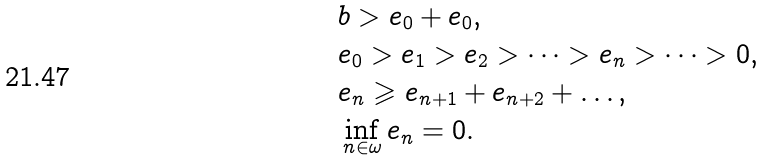Convert formula to latex. <formula><loc_0><loc_0><loc_500><loc_500>& b > e _ { 0 } + e _ { 0 } , \\ & e _ { 0 } > e _ { 1 } > e _ { 2 } > \dots > e _ { n } > \dots > 0 , \\ & e _ { n } \geqslant e _ { n + 1 } + e _ { n + 2 } + \dots , \\ & \inf _ { n \in \omega } e _ { n } = 0 .</formula> 